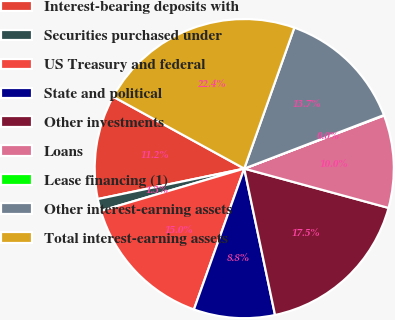Convert chart to OTSL. <chart><loc_0><loc_0><loc_500><loc_500><pie_chart><fcel>Interest-bearing deposits with<fcel>Securities purchased under<fcel>US Treasury and federal<fcel>State and political<fcel>Other investments<fcel>Loans<fcel>Lease financing (1)<fcel>Other interest-earning assets<fcel>Total interest-earning assets<nl><fcel>11.25%<fcel>1.3%<fcel>14.98%<fcel>8.76%<fcel>17.47%<fcel>10.01%<fcel>0.05%<fcel>13.74%<fcel>22.45%<nl></chart> 